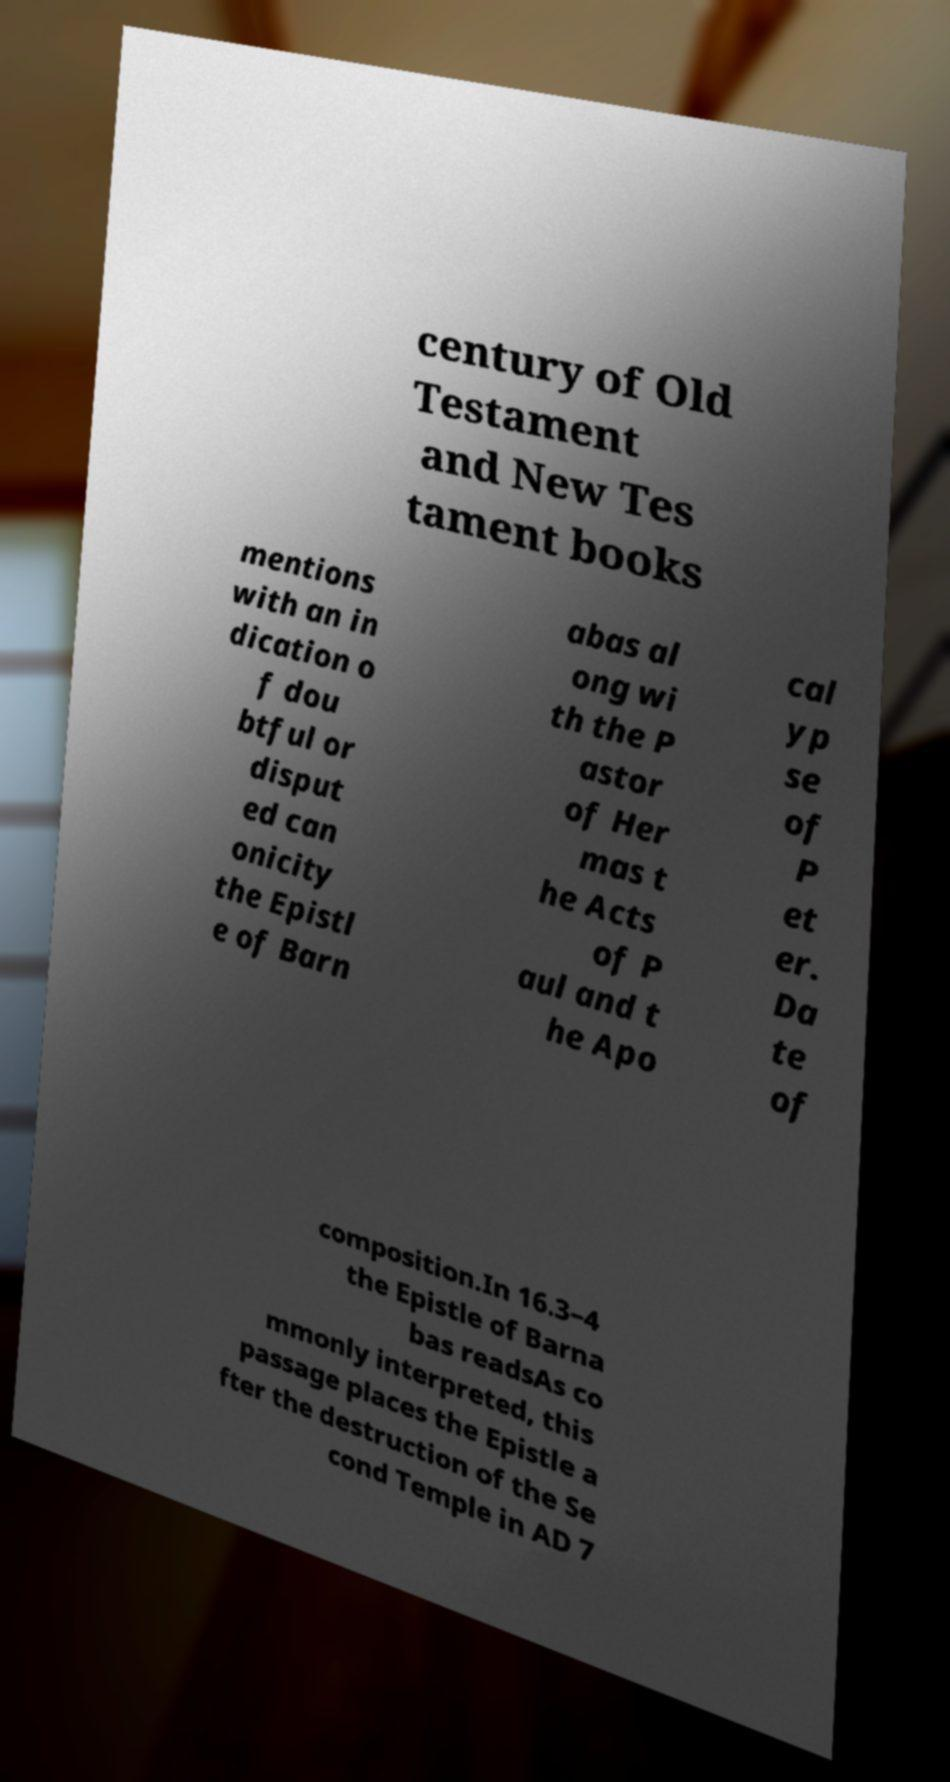Could you extract and type out the text from this image? century of Old Testament and New Tes tament books mentions with an in dication o f dou btful or disput ed can onicity the Epistl e of Barn abas al ong wi th the P astor of Her mas t he Acts of P aul and t he Apo cal yp se of P et er. Da te of composition.In 16.3–4 the Epistle of Barna bas readsAs co mmonly interpreted, this passage places the Epistle a fter the destruction of the Se cond Temple in AD 7 